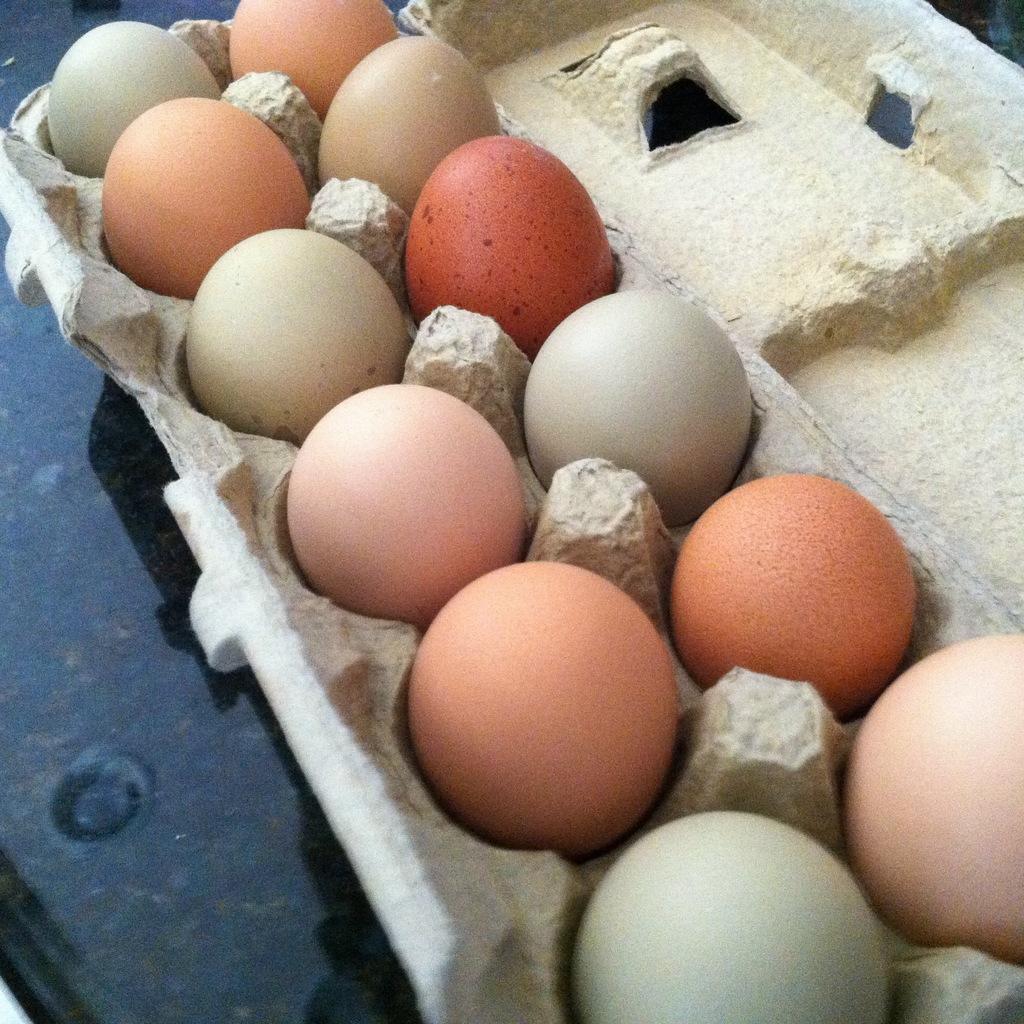Could you give a brief overview of what you see in this image? In this image we can see eggs in a tray. At the bottom of the image there is a black color surface. 